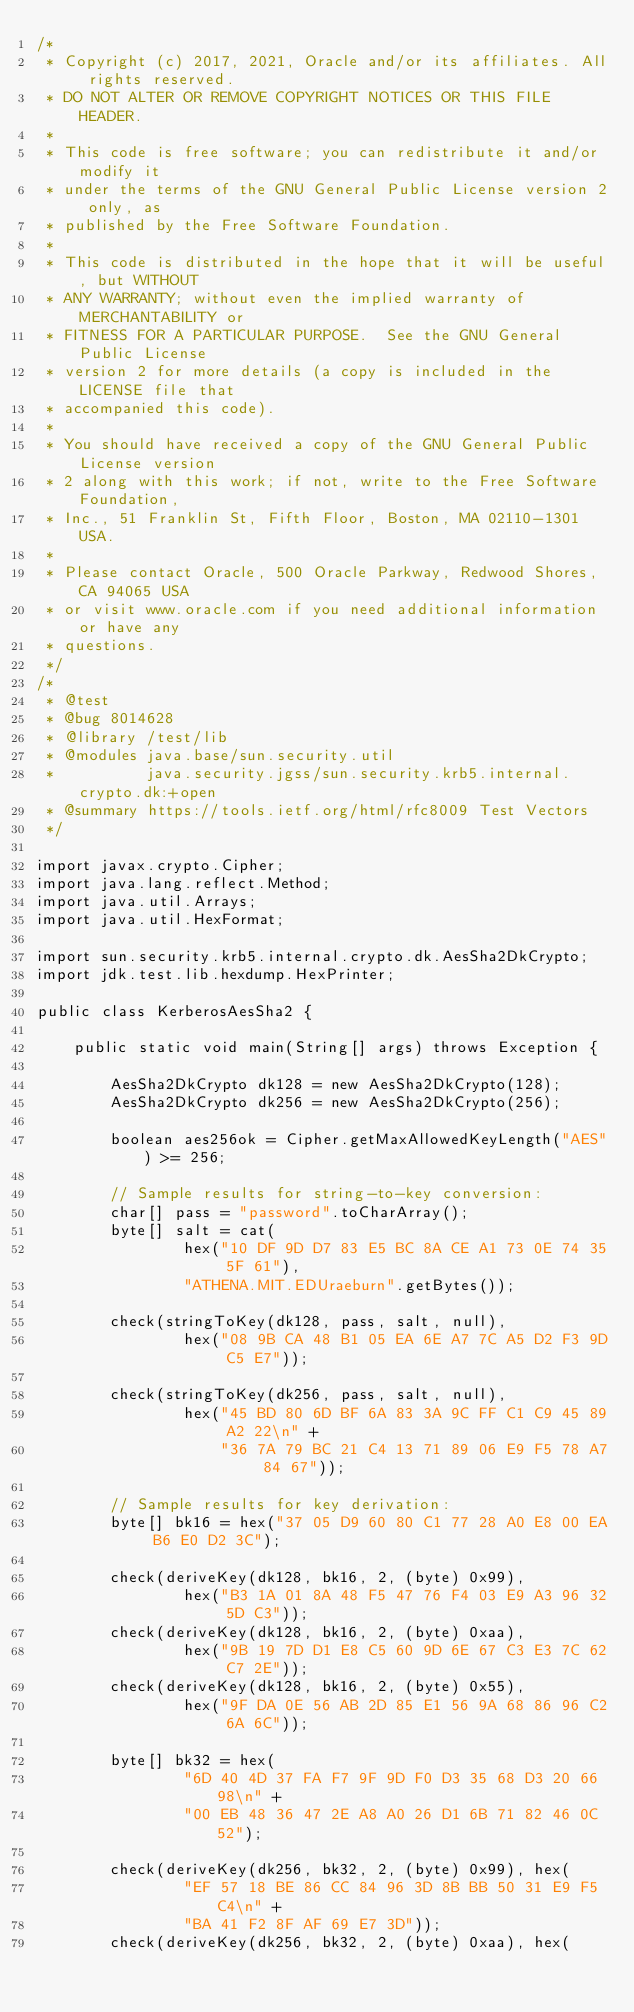Convert code to text. <code><loc_0><loc_0><loc_500><loc_500><_Java_>/*
 * Copyright (c) 2017, 2021, Oracle and/or its affiliates. All rights reserved.
 * DO NOT ALTER OR REMOVE COPYRIGHT NOTICES OR THIS FILE HEADER.
 *
 * This code is free software; you can redistribute it and/or modify it
 * under the terms of the GNU General Public License version 2 only, as
 * published by the Free Software Foundation.
 *
 * This code is distributed in the hope that it will be useful, but WITHOUT
 * ANY WARRANTY; without even the implied warranty of MERCHANTABILITY or
 * FITNESS FOR A PARTICULAR PURPOSE.  See the GNU General Public License
 * version 2 for more details (a copy is included in the LICENSE file that
 * accompanied this code).
 *
 * You should have received a copy of the GNU General Public License version
 * 2 along with this work; if not, write to the Free Software Foundation,
 * Inc., 51 Franklin St, Fifth Floor, Boston, MA 02110-1301 USA.
 *
 * Please contact Oracle, 500 Oracle Parkway, Redwood Shores, CA 94065 USA
 * or visit www.oracle.com if you need additional information or have any
 * questions.
 */
/*
 * @test
 * @bug 8014628
 * @library /test/lib
 * @modules java.base/sun.security.util
 *          java.security.jgss/sun.security.krb5.internal.crypto.dk:+open
 * @summary https://tools.ietf.org/html/rfc8009 Test Vectors
 */

import javax.crypto.Cipher;
import java.lang.reflect.Method;
import java.util.Arrays;
import java.util.HexFormat;

import sun.security.krb5.internal.crypto.dk.AesSha2DkCrypto;
import jdk.test.lib.hexdump.HexPrinter;

public class KerberosAesSha2 {

    public static void main(String[] args) throws Exception {

        AesSha2DkCrypto dk128 = new AesSha2DkCrypto(128);
        AesSha2DkCrypto dk256 = new AesSha2DkCrypto(256);

        boolean aes256ok = Cipher.getMaxAllowedKeyLength("AES") >= 256;

        // Sample results for string-to-key conversion:
        char[] pass = "password".toCharArray();
        byte[] salt = cat(
                hex("10 DF 9D D7 83 E5 BC 8A CE A1 73 0E 74 35 5F 61"),
                "ATHENA.MIT.EDUraeburn".getBytes());

        check(stringToKey(dk128, pass, salt, null),
                hex("08 9B CA 48 B1 05 EA 6E A7 7C A5 D2 F3 9D C5 E7"));

        check(stringToKey(dk256, pass, salt, null),
                hex("45 BD 80 6D BF 6A 83 3A 9C FF C1 C9 45 89 A2 22\n" +
                    "36 7A 79 BC 21 C4 13 71 89 06 E9 F5 78 A7 84 67"));

        // Sample results for key derivation:
        byte[] bk16 = hex("37 05 D9 60 80 C1 77 28 A0 E8 00 EA B6 E0 D2 3C");

        check(deriveKey(dk128, bk16, 2, (byte) 0x99),
                hex("B3 1A 01 8A 48 F5 47 76 F4 03 E9 A3 96 32 5D C3"));
        check(deriveKey(dk128, bk16, 2, (byte) 0xaa),
                hex("9B 19 7D D1 E8 C5 60 9D 6E 67 C3 E3 7C 62 C7 2E"));
        check(deriveKey(dk128, bk16, 2, (byte) 0x55),
                hex("9F DA 0E 56 AB 2D 85 E1 56 9A 68 86 96 C2 6A 6C"));

        byte[] bk32 = hex(
                "6D 40 4D 37 FA F7 9F 9D F0 D3 35 68 D3 20 66 98\n" +
                "00 EB 48 36 47 2E A8 A0 26 D1 6B 71 82 46 0C 52");

        check(deriveKey(dk256, bk32, 2, (byte) 0x99), hex(
                "EF 57 18 BE 86 CC 84 96 3D 8B BB 50 31 E9 F5 C4\n" +
                "BA 41 F2 8F AF 69 E7 3D"));
        check(deriveKey(dk256, bk32, 2, (byte) 0xaa), hex(</code> 